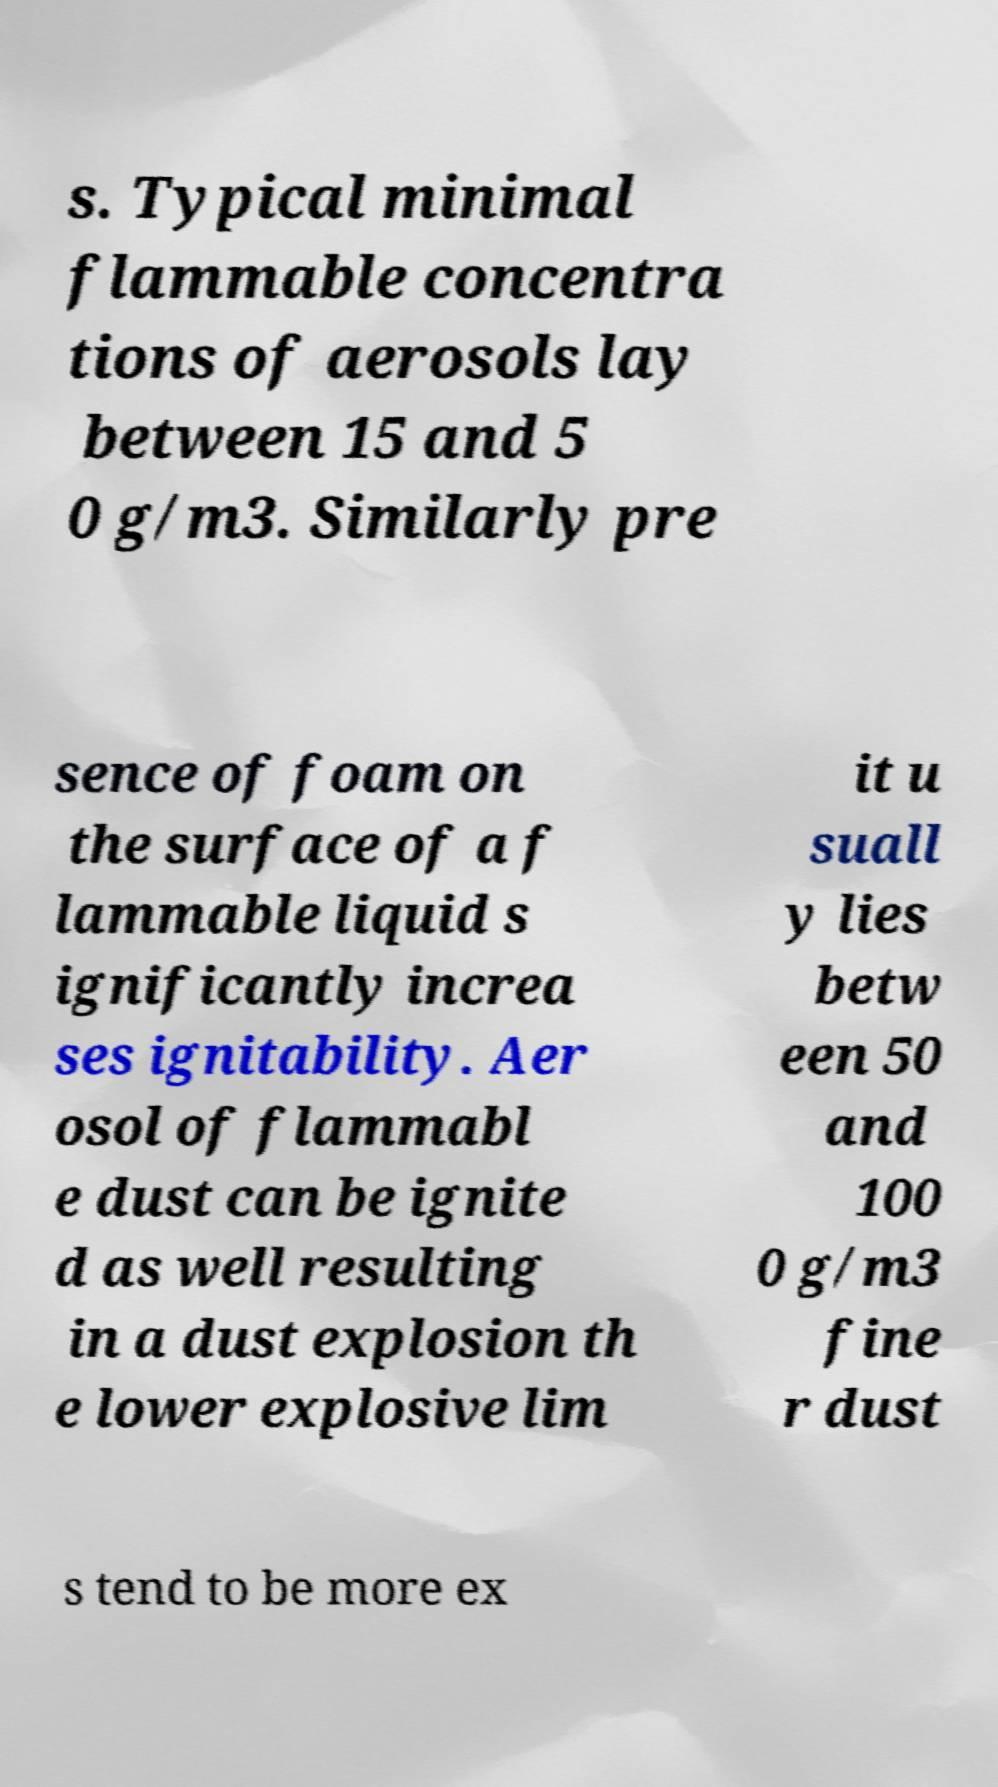What messages or text are displayed in this image? I need them in a readable, typed format. s. Typical minimal flammable concentra tions of aerosols lay between 15 and 5 0 g/m3. Similarly pre sence of foam on the surface of a f lammable liquid s ignificantly increa ses ignitability. Aer osol of flammabl e dust can be ignite d as well resulting in a dust explosion th e lower explosive lim it u suall y lies betw een 50 and 100 0 g/m3 fine r dust s tend to be more ex 